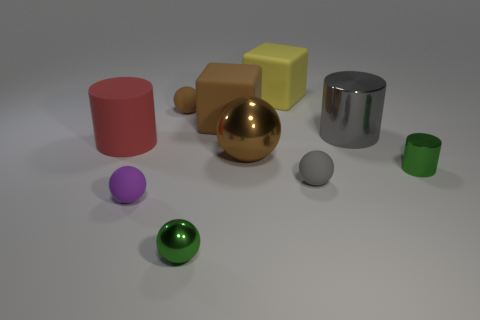What size is the rubber object that is to the right of the large matte object that is right of the brown sphere that is in front of the matte cylinder?
Offer a terse response. Small. There is a green object that is in front of the small cylinder; what size is it?
Provide a short and direct response. Small. What number of things are either large brown balls or big matte blocks on the right side of the big brown shiny object?
Your response must be concise. 2. What number of other things are the same size as the gray rubber ball?
Offer a very short reply. 4. What material is the green object that is the same shape as the small purple matte object?
Provide a succinct answer. Metal. Are there more gray things behind the small brown matte object than large brown rubber cubes?
Keep it short and to the point. No. Is there anything else that is the same color as the large metallic cylinder?
Provide a succinct answer. Yes. What is the shape of the big yellow thing that is made of the same material as the red cylinder?
Give a very brief answer. Cube. Is the green thing that is on the left side of the large brown matte block made of the same material as the big gray cylinder?
Keep it short and to the point. Yes. What is the shape of the small object that is the same color as the small metal sphere?
Give a very brief answer. Cylinder. 